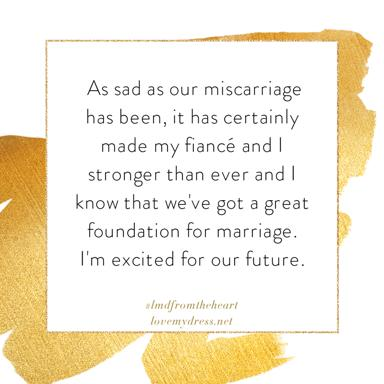What is the main message of the text in the image? The main message conveys a profound sense of resilience and hope, highlighting how a tragic event like a miscarriage has fortified the bond between the couple, solidifying their commitment and optimism for their future marriage. 